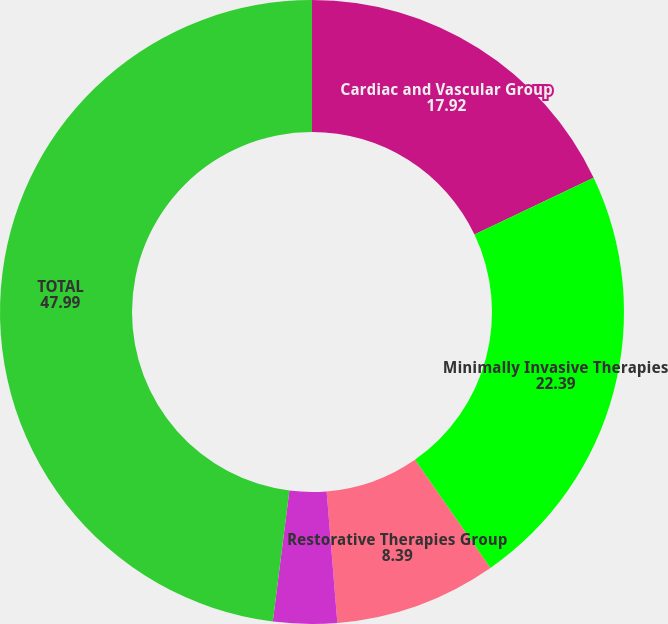<chart> <loc_0><loc_0><loc_500><loc_500><pie_chart><fcel>Cardiac and Vascular Group<fcel>Minimally Invasive Therapies<fcel>Restorative Therapies Group<fcel>Diabetes Group<fcel>TOTAL<nl><fcel>17.92%<fcel>22.39%<fcel>8.39%<fcel>3.3%<fcel>47.99%<nl></chart> 